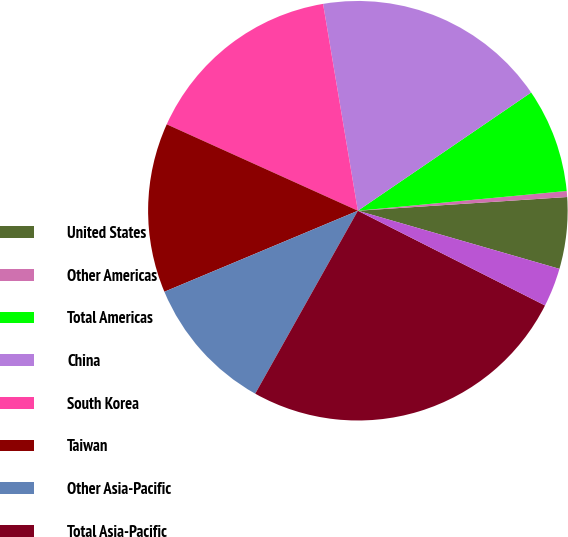<chart> <loc_0><loc_0><loc_500><loc_500><pie_chart><fcel>United States<fcel>Other Americas<fcel>Total Americas<fcel>China<fcel>South Korea<fcel>Taiwan<fcel>Other Asia-Pacific<fcel>Total Asia-Pacific<fcel>Europe Middle East and Africa<nl><fcel>5.51%<fcel>0.46%<fcel>8.03%<fcel>18.12%<fcel>15.59%<fcel>13.07%<fcel>10.55%<fcel>25.68%<fcel>2.99%<nl></chart> 